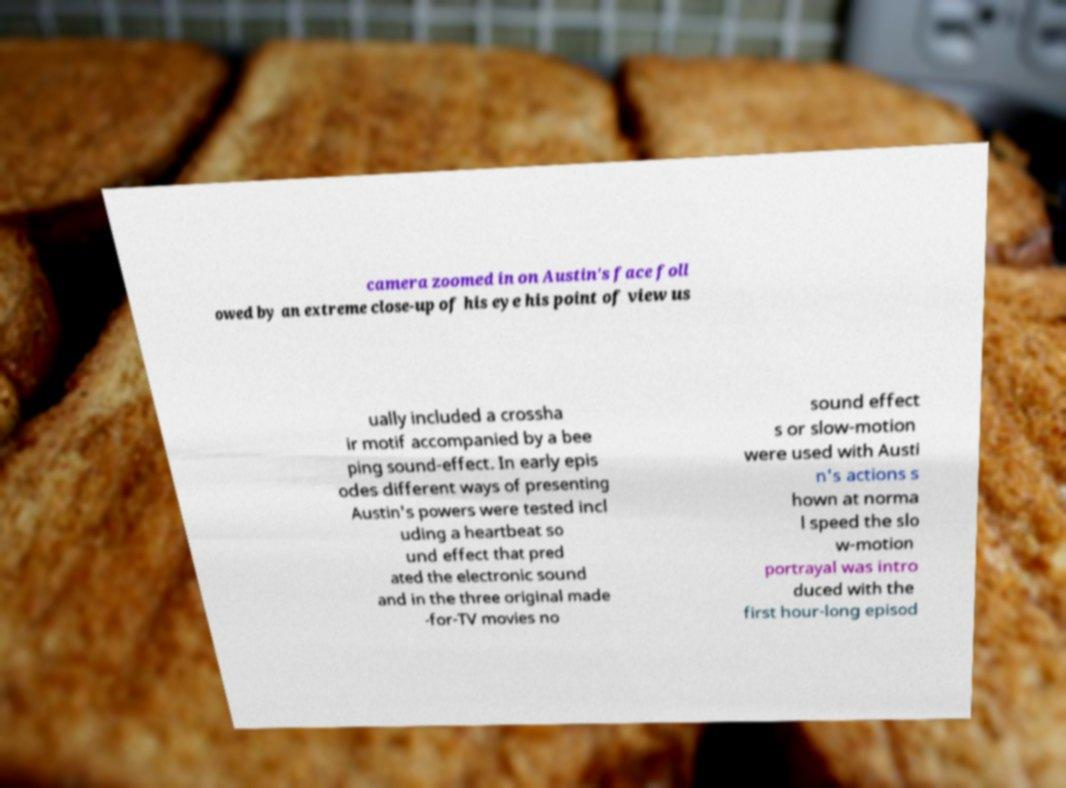Could you assist in decoding the text presented in this image and type it out clearly? camera zoomed in on Austin's face foll owed by an extreme close-up of his eye his point of view us ually included a crossha ir motif accompanied by a bee ping sound-effect. In early epis odes different ways of presenting Austin's powers were tested incl uding a heartbeat so und effect that pred ated the electronic sound and in the three original made -for-TV movies no sound effect s or slow-motion were used with Austi n's actions s hown at norma l speed the slo w-motion portrayal was intro duced with the first hour-long episod 